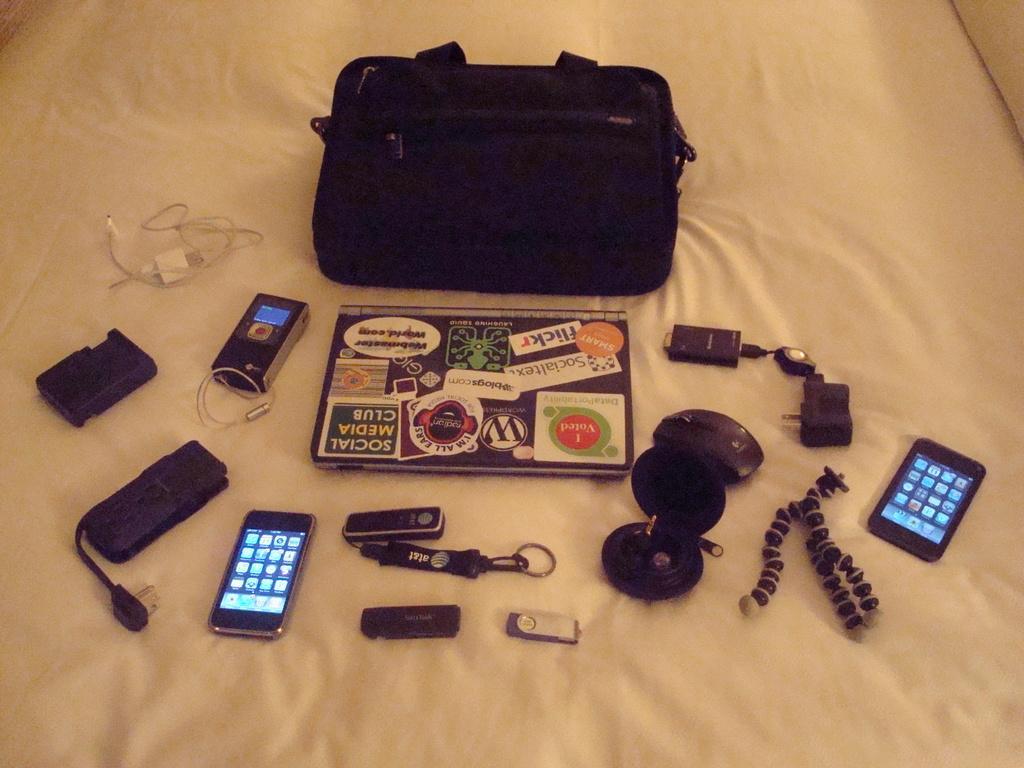In one or two sentences, can you explain what this image depicts? In this picture there are some objects kept on the white cloth, there is a bag, a laptop, smart phone, a cable, another smart phone on to the right, pen drive, voice recorder, and adapter 